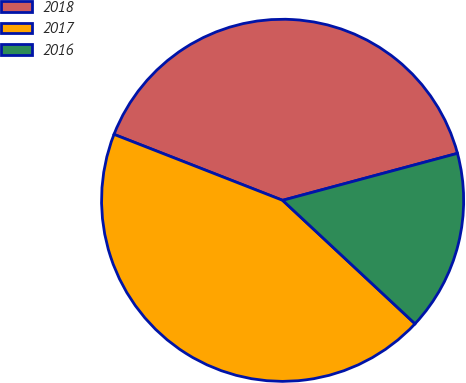Convert chart. <chart><loc_0><loc_0><loc_500><loc_500><pie_chart><fcel>2018<fcel>2017<fcel>2016<nl><fcel>39.89%<fcel>43.99%<fcel>16.12%<nl></chart> 